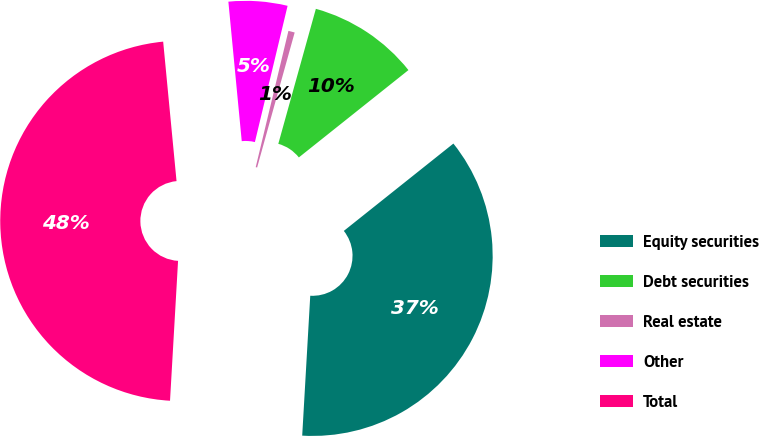Convert chart to OTSL. <chart><loc_0><loc_0><loc_500><loc_500><pie_chart><fcel>Equity securities<fcel>Debt securities<fcel>Real estate<fcel>Other<fcel>Total<nl><fcel>36.62%<fcel>9.97%<fcel>0.57%<fcel>5.27%<fcel>47.56%<nl></chart> 